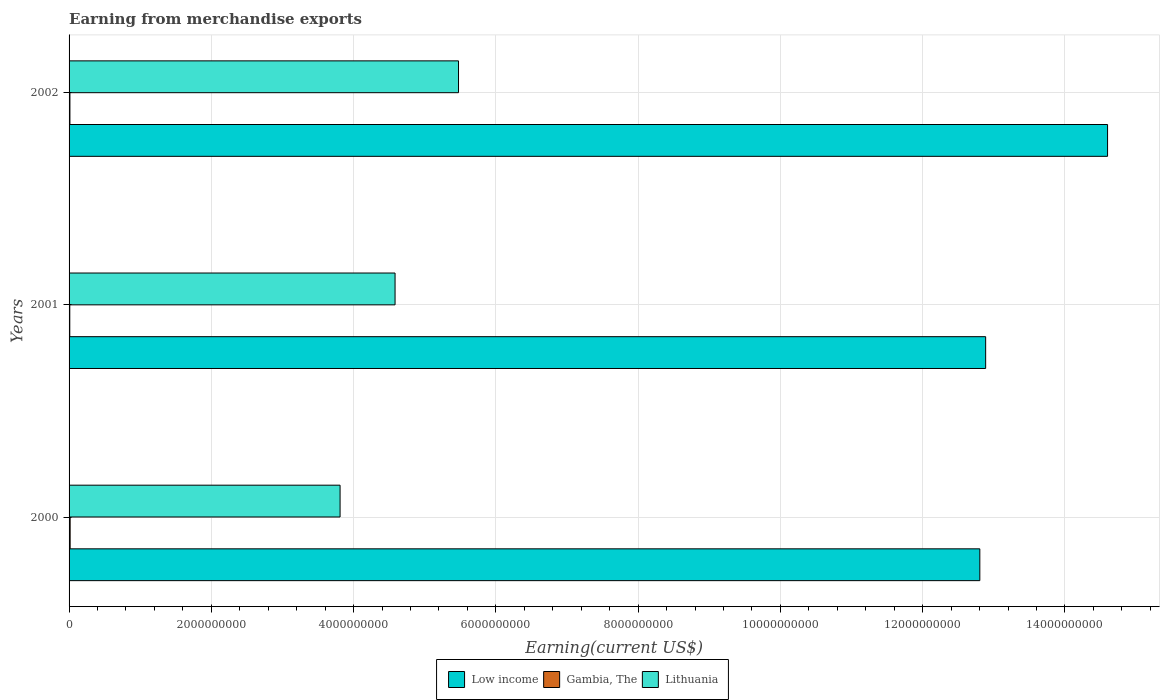How many groups of bars are there?
Make the answer very short. 3. Are the number of bars per tick equal to the number of legend labels?
Make the answer very short. Yes. Are the number of bars on each tick of the Y-axis equal?
Provide a succinct answer. Yes. How many bars are there on the 2nd tick from the top?
Ensure brevity in your answer.  3. What is the label of the 1st group of bars from the top?
Your answer should be very brief. 2002. In how many cases, is the number of bars for a given year not equal to the number of legend labels?
Provide a short and direct response. 0. What is the amount earned from merchandise exports in Gambia, The in 2000?
Offer a terse response. 1.50e+07. Across all years, what is the maximum amount earned from merchandise exports in Lithuania?
Give a very brief answer. 5.48e+09. Across all years, what is the minimum amount earned from merchandise exports in Gambia, The?
Your answer should be very brief. 1.00e+07. What is the total amount earned from merchandise exports in Gambia, The in the graph?
Your answer should be very brief. 3.70e+07. What is the difference between the amount earned from merchandise exports in Lithuania in 2001 and that in 2002?
Give a very brief answer. -8.92e+08. What is the difference between the amount earned from merchandise exports in Gambia, The in 2001 and the amount earned from merchandise exports in Lithuania in 2002?
Ensure brevity in your answer.  -5.46e+09. What is the average amount earned from merchandise exports in Low income per year?
Offer a terse response. 1.34e+1. In the year 2001, what is the difference between the amount earned from merchandise exports in Gambia, The and amount earned from merchandise exports in Low income?
Provide a short and direct response. -1.29e+1. What is the ratio of the amount earned from merchandise exports in Gambia, The in 2000 to that in 2001?
Your response must be concise. 1.5. Is the amount earned from merchandise exports in Low income in 2000 less than that in 2002?
Keep it short and to the point. Yes. What is the difference between the highest and the second highest amount earned from merchandise exports in Low income?
Your answer should be compact. 1.71e+09. What is the difference between the highest and the lowest amount earned from merchandise exports in Gambia, The?
Offer a very short reply. 5.00e+06. Is the sum of the amount earned from merchandise exports in Gambia, The in 2000 and 2001 greater than the maximum amount earned from merchandise exports in Lithuania across all years?
Provide a short and direct response. No. What does the 3rd bar from the top in 2002 represents?
Keep it short and to the point. Low income. What does the 1st bar from the bottom in 2001 represents?
Provide a succinct answer. Low income. How many bars are there?
Your response must be concise. 9. Are all the bars in the graph horizontal?
Provide a short and direct response. Yes. How many years are there in the graph?
Ensure brevity in your answer.  3. What is the difference between two consecutive major ticks on the X-axis?
Give a very brief answer. 2.00e+09. Are the values on the major ticks of X-axis written in scientific E-notation?
Ensure brevity in your answer.  No. Does the graph contain any zero values?
Provide a short and direct response. No. Where does the legend appear in the graph?
Offer a terse response. Bottom center. How many legend labels are there?
Provide a short and direct response. 3. What is the title of the graph?
Offer a very short reply. Earning from merchandise exports. Does "Sub-Saharan Africa (developing only)" appear as one of the legend labels in the graph?
Ensure brevity in your answer.  No. What is the label or title of the X-axis?
Keep it short and to the point. Earning(current US$). What is the label or title of the Y-axis?
Offer a very short reply. Years. What is the Earning(current US$) in Low income in 2000?
Make the answer very short. 1.28e+1. What is the Earning(current US$) in Gambia, The in 2000?
Keep it short and to the point. 1.50e+07. What is the Earning(current US$) of Lithuania in 2000?
Your response must be concise. 3.81e+09. What is the Earning(current US$) of Low income in 2001?
Give a very brief answer. 1.29e+1. What is the Earning(current US$) in Lithuania in 2001?
Provide a short and direct response. 4.58e+09. What is the Earning(current US$) of Low income in 2002?
Give a very brief answer. 1.46e+1. What is the Earning(current US$) of Lithuania in 2002?
Offer a terse response. 5.48e+09. Across all years, what is the maximum Earning(current US$) in Low income?
Your answer should be compact. 1.46e+1. Across all years, what is the maximum Earning(current US$) in Gambia, The?
Offer a very short reply. 1.50e+07. Across all years, what is the maximum Earning(current US$) in Lithuania?
Give a very brief answer. 5.48e+09. Across all years, what is the minimum Earning(current US$) of Low income?
Provide a succinct answer. 1.28e+1. Across all years, what is the minimum Earning(current US$) in Gambia, The?
Offer a very short reply. 1.00e+07. Across all years, what is the minimum Earning(current US$) of Lithuania?
Provide a short and direct response. 3.81e+09. What is the total Earning(current US$) in Low income in the graph?
Provide a short and direct response. 4.03e+1. What is the total Earning(current US$) in Gambia, The in the graph?
Ensure brevity in your answer.  3.70e+07. What is the total Earning(current US$) of Lithuania in the graph?
Offer a terse response. 1.39e+1. What is the difference between the Earning(current US$) of Low income in 2000 and that in 2001?
Provide a succinct answer. -8.18e+07. What is the difference between the Earning(current US$) in Gambia, The in 2000 and that in 2001?
Make the answer very short. 5.00e+06. What is the difference between the Earning(current US$) in Lithuania in 2000 and that in 2001?
Your answer should be compact. -7.73e+08. What is the difference between the Earning(current US$) in Low income in 2000 and that in 2002?
Your response must be concise. -1.80e+09. What is the difference between the Earning(current US$) in Lithuania in 2000 and that in 2002?
Make the answer very short. -1.66e+09. What is the difference between the Earning(current US$) of Low income in 2001 and that in 2002?
Give a very brief answer. -1.71e+09. What is the difference between the Earning(current US$) of Gambia, The in 2001 and that in 2002?
Your answer should be very brief. -2.00e+06. What is the difference between the Earning(current US$) of Lithuania in 2001 and that in 2002?
Your answer should be very brief. -8.92e+08. What is the difference between the Earning(current US$) in Low income in 2000 and the Earning(current US$) in Gambia, The in 2001?
Ensure brevity in your answer.  1.28e+1. What is the difference between the Earning(current US$) of Low income in 2000 and the Earning(current US$) of Lithuania in 2001?
Ensure brevity in your answer.  8.22e+09. What is the difference between the Earning(current US$) in Gambia, The in 2000 and the Earning(current US$) in Lithuania in 2001?
Offer a very short reply. -4.57e+09. What is the difference between the Earning(current US$) in Low income in 2000 and the Earning(current US$) in Gambia, The in 2002?
Make the answer very short. 1.28e+1. What is the difference between the Earning(current US$) of Low income in 2000 and the Earning(current US$) of Lithuania in 2002?
Provide a succinct answer. 7.33e+09. What is the difference between the Earning(current US$) of Gambia, The in 2000 and the Earning(current US$) of Lithuania in 2002?
Keep it short and to the point. -5.46e+09. What is the difference between the Earning(current US$) in Low income in 2001 and the Earning(current US$) in Gambia, The in 2002?
Make the answer very short. 1.29e+1. What is the difference between the Earning(current US$) in Low income in 2001 and the Earning(current US$) in Lithuania in 2002?
Ensure brevity in your answer.  7.41e+09. What is the difference between the Earning(current US$) in Gambia, The in 2001 and the Earning(current US$) in Lithuania in 2002?
Offer a terse response. -5.46e+09. What is the average Earning(current US$) in Low income per year?
Give a very brief answer. 1.34e+1. What is the average Earning(current US$) in Gambia, The per year?
Offer a very short reply. 1.23e+07. What is the average Earning(current US$) in Lithuania per year?
Keep it short and to the point. 4.62e+09. In the year 2000, what is the difference between the Earning(current US$) of Low income and Earning(current US$) of Gambia, The?
Your response must be concise. 1.28e+1. In the year 2000, what is the difference between the Earning(current US$) in Low income and Earning(current US$) in Lithuania?
Your response must be concise. 8.99e+09. In the year 2000, what is the difference between the Earning(current US$) in Gambia, The and Earning(current US$) in Lithuania?
Ensure brevity in your answer.  -3.80e+09. In the year 2001, what is the difference between the Earning(current US$) in Low income and Earning(current US$) in Gambia, The?
Your answer should be compact. 1.29e+1. In the year 2001, what is the difference between the Earning(current US$) in Low income and Earning(current US$) in Lithuania?
Your response must be concise. 8.30e+09. In the year 2001, what is the difference between the Earning(current US$) of Gambia, The and Earning(current US$) of Lithuania?
Offer a terse response. -4.57e+09. In the year 2002, what is the difference between the Earning(current US$) of Low income and Earning(current US$) of Gambia, The?
Your answer should be very brief. 1.46e+1. In the year 2002, what is the difference between the Earning(current US$) in Low income and Earning(current US$) in Lithuania?
Offer a very short reply. 9.12e+09. In the year 2002, what is the difference between the Earning(current US$) of Gambia, The and Earning(current US$) of Lithuania?
Keep it short and to the point. -5.46e+09. What is the ratio of the Earning(current US$) in Gambia, The in 2000 to that in 2001?
Your answer should be compact. 1.5. What is the ratio of the Earning(current US$) of Lithuania in 2000 to that in 2001?
Ensure brevity in your answer.  0.83. What is the ratio of the Earning(current US$) of Low income in 2000 to that in 2002?
Offer a very short reply. 0.88. What is the ratio of the Earning(current US$) in Lithuania in 2000 to that in 2002?
Offer a very short reply. 0.7. What is the ratio of the Earning(current US$) in Low income in 2001 to that in 2002?
Your answer should be compact. 0.88. What is the ratio of the Earning(current US$) of Lithuania in 2001 to that in 2002?
Ensure brevity in your answer.  0.84. What is the difference between the highest and the second highest Earning(current US$) in Low income?
Offer a very short reply. 1.71e+09. What is the difference between the highest and the second highest Earning(current US$) of Gambia, The?
Provide a short and direct response. 3.00e+06. What is the difference between the highest and the second highest Earning(current US$) of Lithuania?
Provide a short and direct response. 8.92e+08. What is the difference between the highest and the lowest Earning(current US$) of Low income?
Your response must be concise. 1.80e+09. What is the difference between the highest and the lowest Earning(current US$) in Lithuania?
Offer a very short reply. 1.66e+09. 